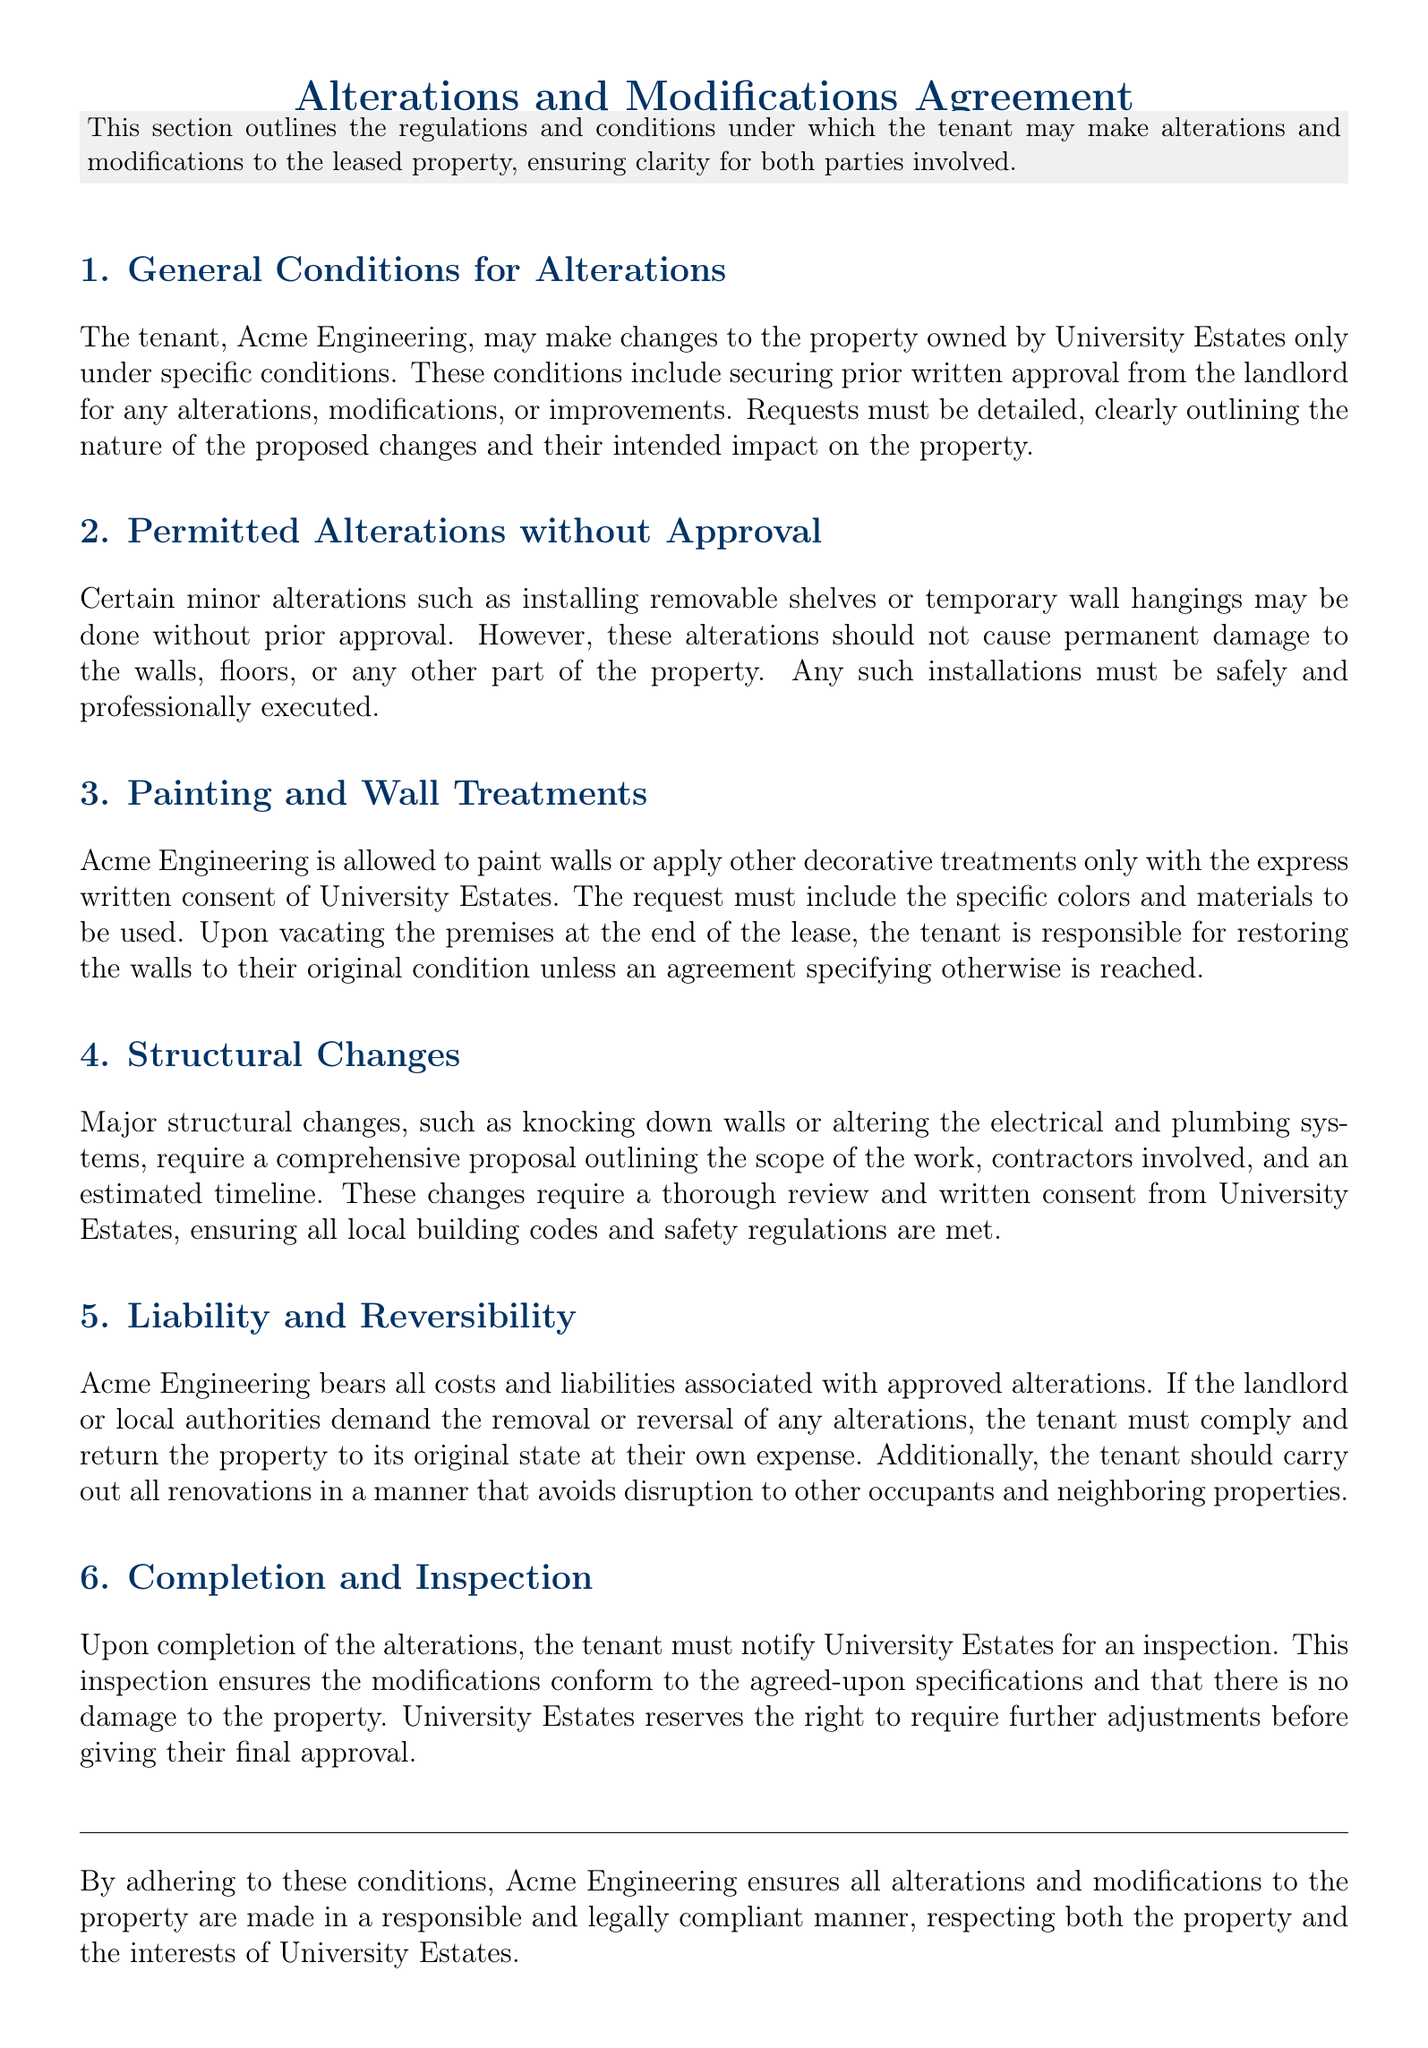What are the conditions for the tenant to make alterations? The tenant must secure prior written approval from the landlord for any alterations, modifications, or improvements.
Answer: Prior written approval What minor alterations can be made without approval? Minor alterations such as installing removable shelves or temporary wall hangings may be done without prior approval.
Answer: Removable shelves What is required for painting the walls? Painting requires express written consent from the landlord, specifying colors and materials.
Answer: Written consent What must the tenant do upon vacating the premises? The tenant is responsible for restoring the walls to their original condition unless specified otherwise.
Answer: Restore to original condition Who bears the costs associated with approved alterations? Acme Engineering bears all costs and liabilities associated with approved alterations.
Answer: Acme Engineering What is needed for major structural changes? A comprehensive proposal outlining the scope of work, contractors involved, and an estimated timeline is required.
Answer: Comprehensive proposal What does the tenant need to do after completing alterations? The tenant must notify the landlord for an inspection.
Answer: Notify for inspection What happens if local authorities demand alterations to be reversed? The tenant must comply and return the property to its original state at their own expense.
Answer: Return to original state 